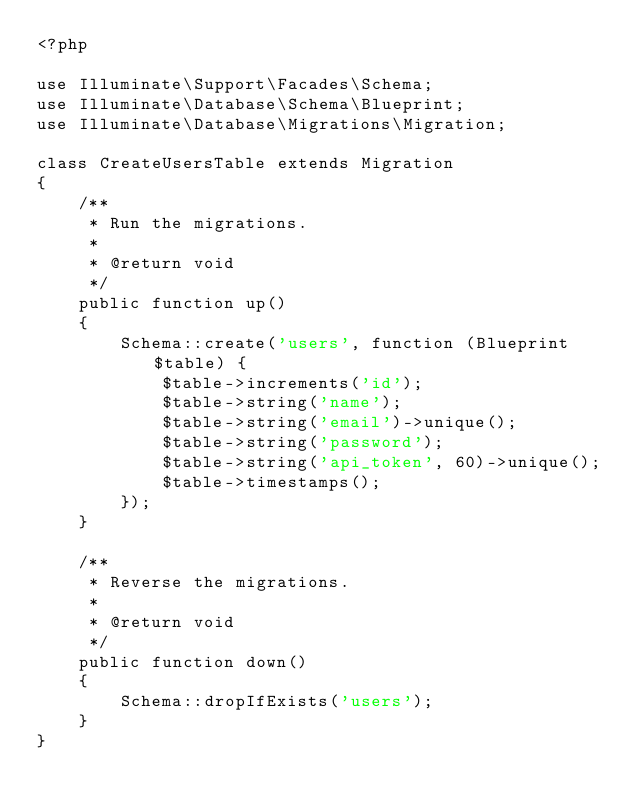<code> <loc_0><loc_0><loc_500><loc_500><_PHP_><?php

use Illuminate\Support\Facades\Schema;
use Illuminate\Database\Schema\Blueprint;
use Illuminate\Database\Migrations\Migration;

class CreateUsersTable extends Migration
{
    /**
     * Run the migrations.
     *
     * @return void
     */
    public function up()
    {
        Schema::create('users', function (Blueprint $table) {
            $table->increments('id');
            $table->string('name');
            $table->string('email')->unique();
            $table->string('password');
            $table->string('api_token', 60)->unique();
            $table->timestamps();
        });
    }

    /**
     * Reverse the migrations.
     *
     * @return void
     */
    public function down()
    {
        Schema::dropIfExists('users');
    }
}
</code> 